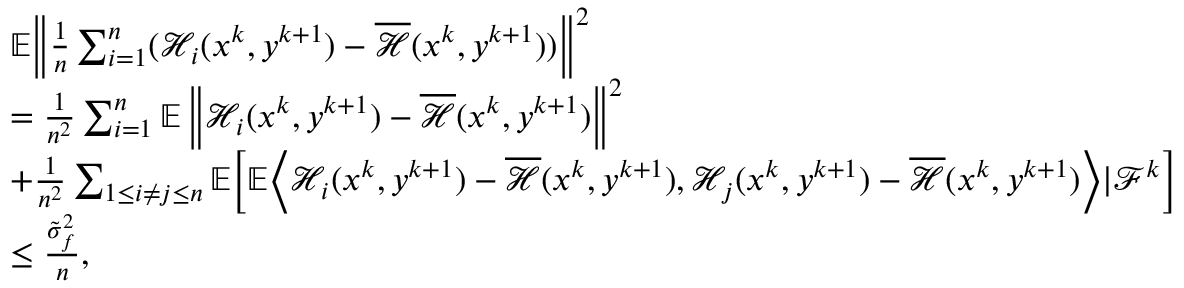Convert formula to latex. <formula><loc_0><loc_0><loc_500><loc_500>\begin{array} { r l } & { \mathbb { E } \left \| \frac { 1 } { n } \sum _ { i = 1 } ^ { n } ( \mathcal { H } _ { i } ( x ^ { k } , y ^ { k + 1 } ) - \overline { { \mathcal { H } } } ( x ^ { k } , y ^ { k + 1 } ) ) \right \| ^ { 2 } } \\ & { = \frac { 1 } { n ^ { 2 } } \sum _ { i = 1 } ^ { n } \mathbb { E } \left \| \mathcal { H } _ { i } ( x ^ { k } , y ^ { k + 1 } ) - \overline { { \mathcal { H } } } ( x ^ { k } , y ^ { k + 1 } ) \right \| ^ { 2 } } \\ & { + \frac { 1 } { n ^ { 2 } } \sum _ { 1 \leq i \neq j \leq n } \mathbb { E } \left [ \mathbb { E } \left \langle \mathcal { H } _ { i } ( x ^ { k } , y ^ { k + 1 } ) - \overline { { \mathcal { H } } } ( x ^ { k } , y ^ { k + 1 } ) , \mathcal { H } _ { j } ( x ^ { k } , y ^ { k + 1 } ) - \overline { { \mathcal { H } } } ( x ^ { k } , y ^ { k + 1 } ) \right \rangle | \mathcal { F } ^ { k } \right ] } \\ & { \leq \frac { \tilde { \sigma } _ { f } ^ { 2 } } { n } , } \end{array}</formula> 